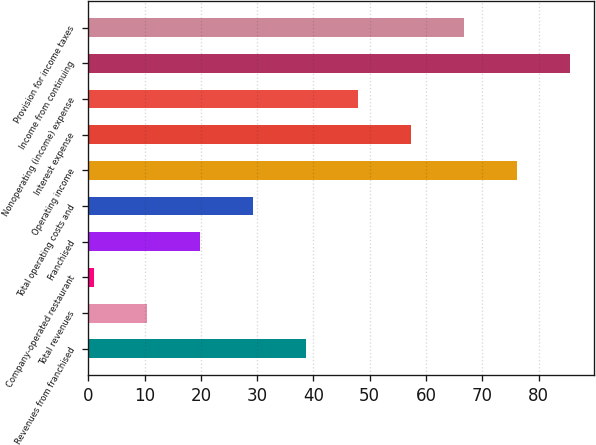Convert chart. <chart><loc_0><loc_0><loc_500><loc_500><bar_chart><fcel>Revenues from franchised<fcel>Total revenues<fcel>Company-operated restaurant<fcel>Franchised<fcel>Total operating costs and<fcel>Operating income<fcel>Interest expense<fcel>Nonoperating (income) expense<fcel>Income from continuing<fcel>Provision for income taxes<nl><fcel>38.6<fcel>10.4<fcel>1<fcel>19.8<fcel>29.2<fcel>76.2<fcel>57.4<fcel>48<fcel>85.6<fcel>66.8<nl></chart> 